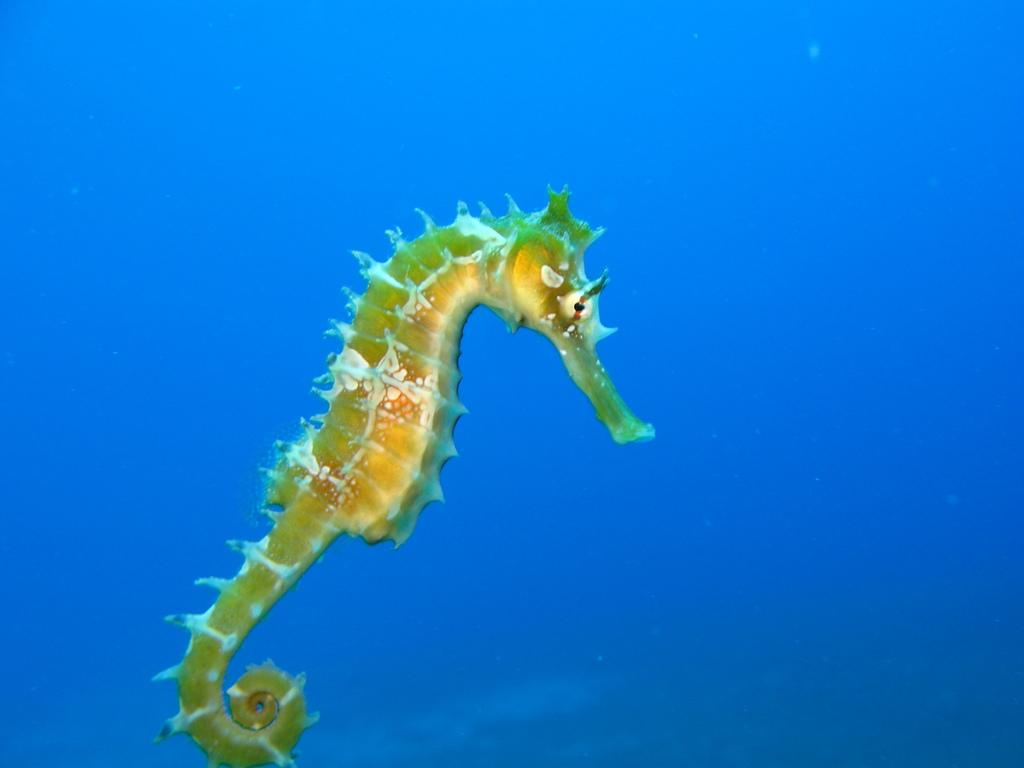What type of animal is in the image? There is a seahorse in the image. Can you describe the color of the seahorse? The seahorse is white and brown in color. What color is the background of the image? The background of the image is blue. How many times does the seahorse sneeze in the image? Seahorses do not sneeze, and there is no indication of sneezing in the image. 